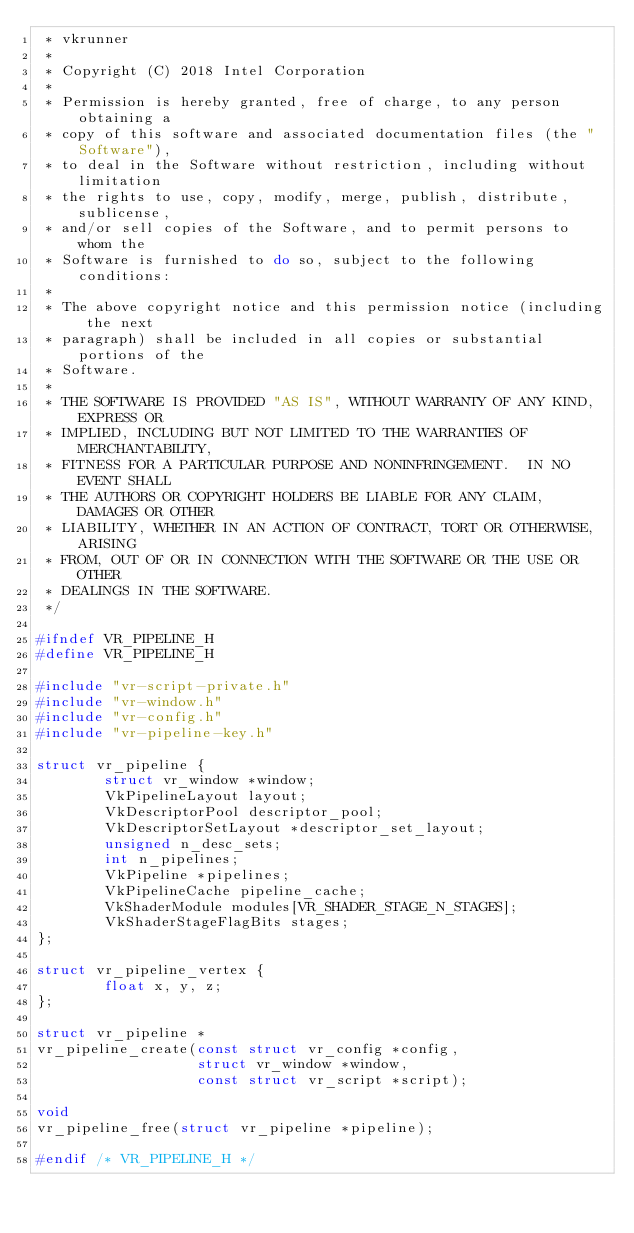<code> <loc_0><loc_0><loc_500><loc_500><_C_> * vkrunner
 *
 * Copyright (C) 2018 Intel Corporation
 *
 * Permission is hereby granted, free of charge, to any person obtaining a
 * copy of this software and associated documentation files (the "Software"),
 * to deal in the Software without restriction, including without limitation
 * the rights to use, copy, modify, merge, publish, distribute, sublicense,
 * and/or sell copies of the Software, and to permit persons to whom the
 * Software is furnished to do so, subject to the following conditions:
 *
 * The above copyright notice and this permission notice (including the next
 * paragraph) shall be included in all copies or substantial portions of the
 * Software.
 *
 * THE SOFTWARE IS PROVIDED "AS IS", WITHOUT WARRANTY OF ANY KIND, EXPRESS OR
 * IMPLIED, INCLUDING BUT NOT LIMITED TO THE WARRANTIES OF MERCHANTABILITY,
 * FITNESS FOR A PARTICULAR PURPOSE AND NONINFRINGEMENT.  IN NO EVENT SHALL
 * THE AUTHORS OR COPYRIGHT HOLDERS BE LIABLE FOR ANY CLAIM, DAMAGES OR OTHER
 * LIABILITY, WHETHER IN AN ACTION OF CONTRACT, TORT OR OTHERWISE, ARISING
 * FROM, OUT OF OR IN CONNECTION WITH THE SOFTWARE OR THE USE OR OTHER
 * DEALINGS IN THE SOFTWARE.
 */

#ifndef VR_PIPELINE_H
#define VR_PIPELINE_H

#include "vr-script-private.h"
#include "vr-window.h"
#include "vr-config.h"
#include "vr-pipeline-key.h"

struct vr_pipeline {
        struct vr_window *window;
        VkPipelineLayout layout;
        VkDescriptorPool descriptor_pool;
        VkDescriptorSetLayout *descriptor_set_layout;
        unsigned n_desc_sets;
        int n_pipelines;
        VkPipeline *pipelines;
        VkPipelineCache pipeline_cache;
        VkShaderModule modules[VR_SHADER_STAGE_N_STAGES];
        VkShaderStageFlagBits stages;
};

struct vr_pipeline_vertex {
        float x, y, z;
};

struct vr_pipeline *
vr_pipeline_create(const struct vr_config *config,
                   struct vr_window *window,
                   const struct vr_script *script);

void
vr_pipeline_free(struct vr_pipeline *pipeline);

#endif /* VR_PIPELINE_H */
</code> 